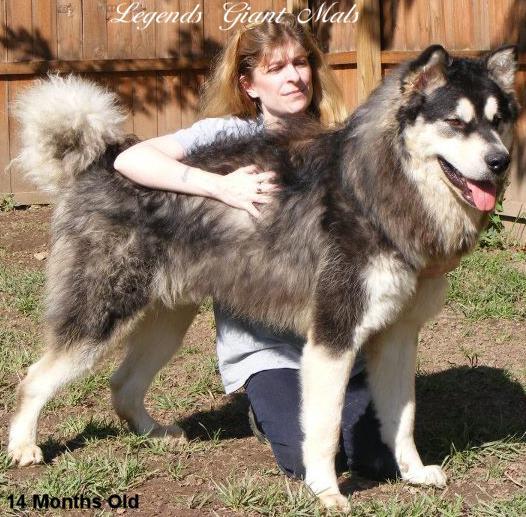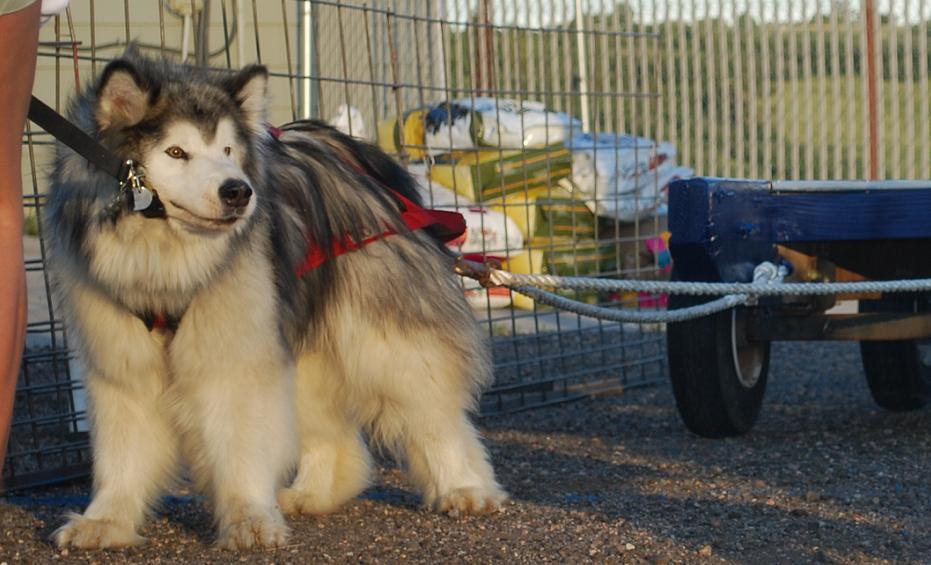The first image is the image on the left, the second image is the image on the right. Examine the images to the left and right. Is the description "The left image features one standing open-mouthed dog, and the right image features one standing close-mouthed dog." accurate? Answer yes or no. Yes. 